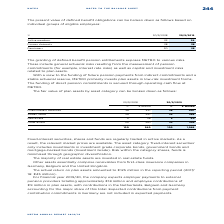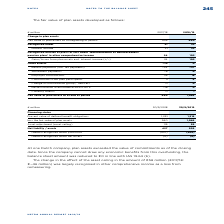According to Metro Ag's financial document, How much did the actual return on plan assets amount to in FY2019? According to the financial document, €125 million. The relevant text states: "The actual return on plan assets amounted to €125 million in the reporting period (2017/..." Also, What is not included in expected payments? Based on the financial document, the answer is Expected contributions from payment contribution commitments in Germany. Also, For which years was the Fair value of plan assets as of end of period calculated in? The document shows two values: 2018 and 2019. From the document: "% 30/9/2018 30/9/2019 % 30/9/2018 30/9/2019..." Additionally, In which year was Interest income larger? According to the financial document, 2019. The relevant text states: "% 30/9/2018 30/9/2019..." Also, can you calculate: What was the change in interest income in FY2019 from FY2018? Based on the calculation: 23-21, the result is 2 (in millions). This is based on the information: "Recognised under 21 23 Recognised under 21 23..." The key data points involved are: 21, 23. Also, can you calculate: What was the percentage change in interest income in FY2019 from FY2018? To answer this question, I need to perform calculations using the financial data. The calculation is: (23-21)/21, which equals 9.52 (percentage). This is based on the information: "Recognised under 21 23 Recognised under 21 23..." The key data points involved are: 21, 23. 